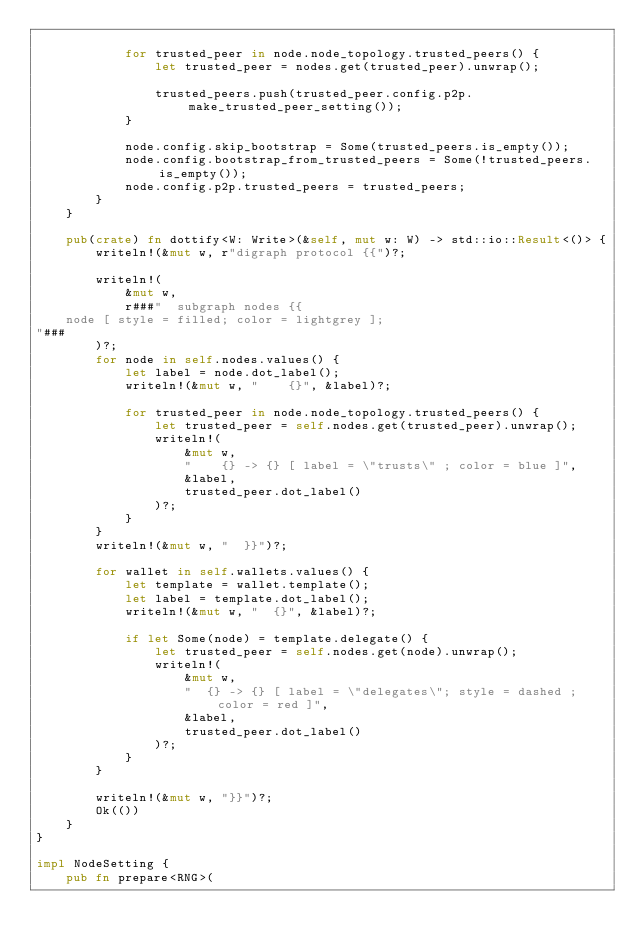Convert code to text. <code><loc_0><loc_0><loc_500><loc_500><_Rust_>
            for trusted_peer in node.node_topology.trusted_peers() {
                let trusted_peer = nodes.get(trusted_peer).unwrap();

                trusted_peers.push(trusted_peer.config.p2p.make_trusted_peer_setting());
            }

            node.config.skip_bootstrap = Some(trusted_peers.is_empty());
            node.config.bootstrap_from_trusted_peers = Some(!trusted_peers.is_empty());
            node.config.p2p.trusted_peers = trusted_peers;
        }
    }

    pub(crate) fn dottify<W: Write>(&self, mut w: W) -> std::io::Result<()> {
        writeln!(&mut w, r"digraph protocol {{")?;

        writeln!(
            &mut w,
            r###"  subgraph nodes {{
    node [ style = filled; color = lightgrey ];
"###
        )?;
        for node in self.nodes.values() {
            let label = node.dot_label();
            writeln!(&mut w, "    {}", &label)?;

            for trusted_peer in node.node_topology.trusted_peers() {
                let trusted_peer = self.nodes.get(trusted_peer).unwrap();
                writeln!(
                    &mut w,
                    "    {} -> {} [ label = \"trusts\" ; color = blue ]",
                    &label,
                    trusted_peer.dot_label()
                )?;
            }
        }
        writeln!(&mut w, "  }}")?;

        for wallet in self.wallets.values() {
            let template = wallet.template();
            let label = template.dot_label();
            writeln!(&mut w, "  {}", &label)?;

            if let Some(node) = template.delegate() {
                let trusted_peer = self.nodes.get(node).unwrap();
                writeln!(
                    &mut w,
                    "  {} -> {} [ label = \"delegates\"; style = dashed ; color = red ]",
                    &label,
                    trusted_peer.dot_label()
                )?;
            }
        }

        writeln!(&mut w, "}}")?;
        Ok(())
    }
}

impl NodeSetting {
    pub fn prepare<RNG>(</code> 